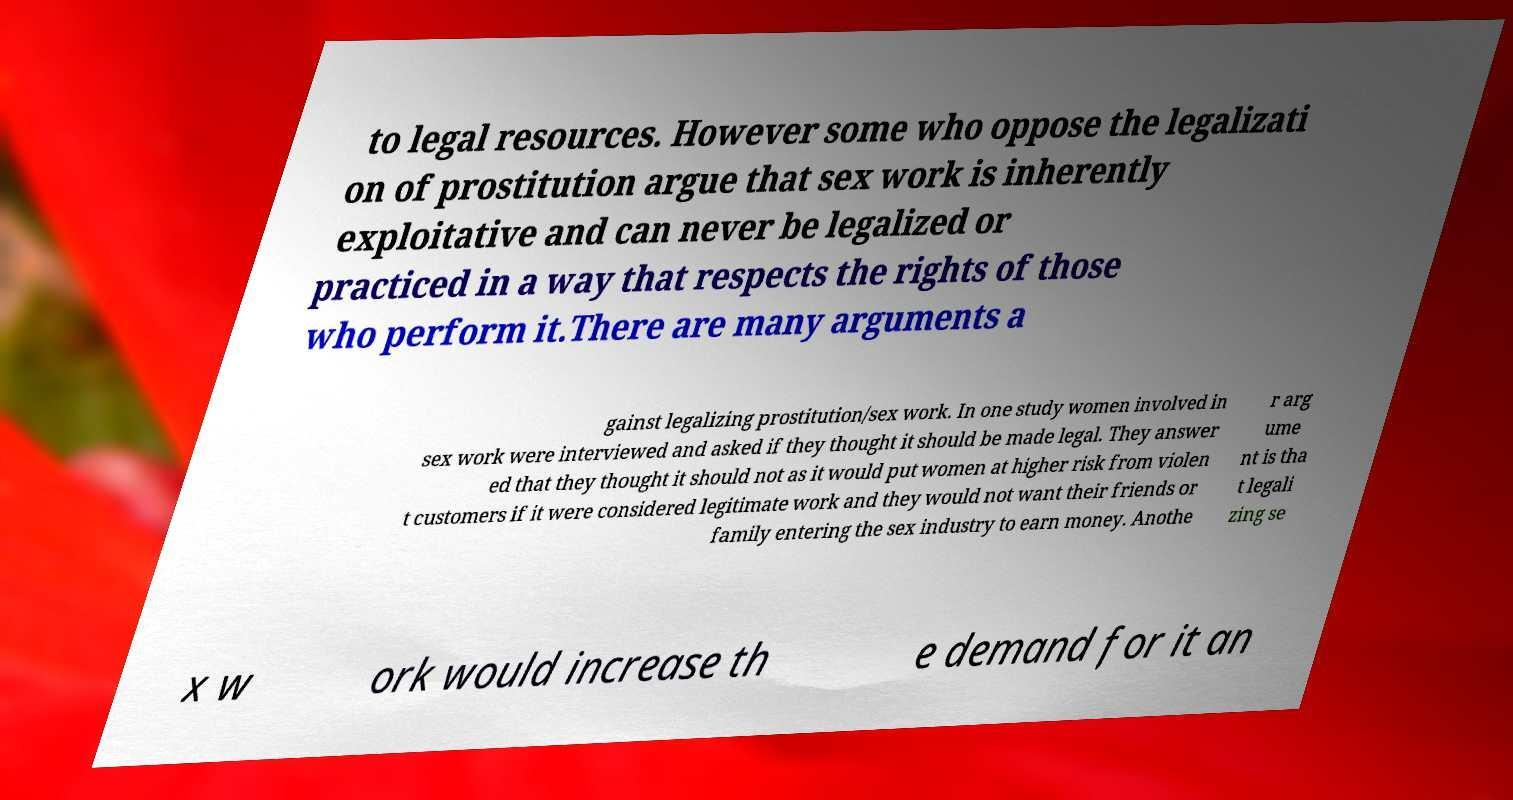What messages or text are displayed in this image? I need them in a readable, typed format. to legal resources. However some who oppose the legalizati on of prostitution argue that sex work is inherently exploitative and can never be legalized or practiced in a way that respects the rights of those who perform it.There are many arguments a gainst legalizing prostitution/sex work. In one study women involved in sex work were interviewed and asked if they thought it should be made legal. They answer ed that they thought it should not as it would put women at higher risk from violen t customers if it were considered legitimate work and they would not want their friends or family entering the sex industry to earn money. Anothe r arg ume nt is tha t legali zing se x w ork would increase th e demand for it an 